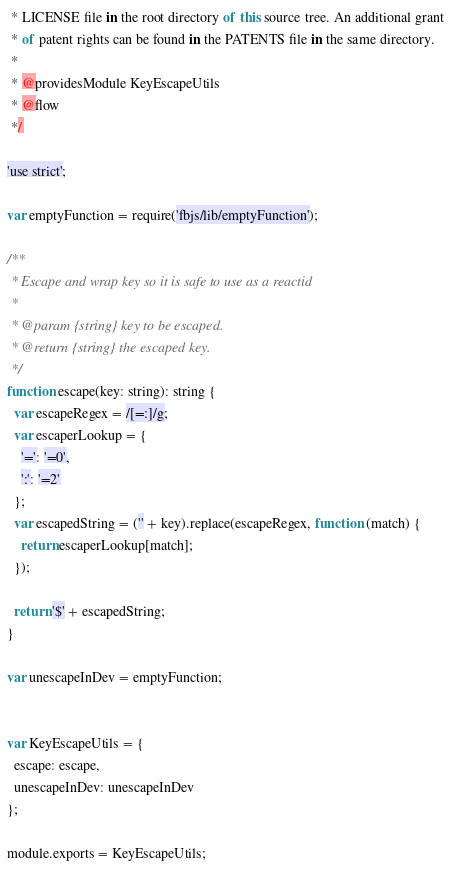<code> <loc_0><loc_0><loc_500><loc_500><_JavaScript_> * LICENSE file in the root directory of this source tree. An additional grant
 * of patent rights can be found in the PATENTS file in the same directory.
 *
 * @providesModule KeyEscapeUtils
 * @flow
 */

'use strict';

var emptyFunction = require('fbjs/lib/emptyFunction');

/**
 * Escape and wrap key so it is safe to use as a reactid
 *
 * @param {string} key to be escaped.
 * @return {string} the escaped key.
 */
function escape(key: string): string {
  var escapeRegex = /[=:]/g;
  var escaperLookup = {
    '=': '=0',
    ':': '=2'
  };
  var escapedString = ('' + key).replace(escapeRegex, function (match) {
    return escaperLookup[match];
  });

  return '$' + escapedString;
}

var unescapeInDev = emptyFunction;


var KeyEscapeUtils = {
  escape: escape,
  unescapeInDev: unescapeInDev
};

module.exports = KeyEscapeUtils;</code> 